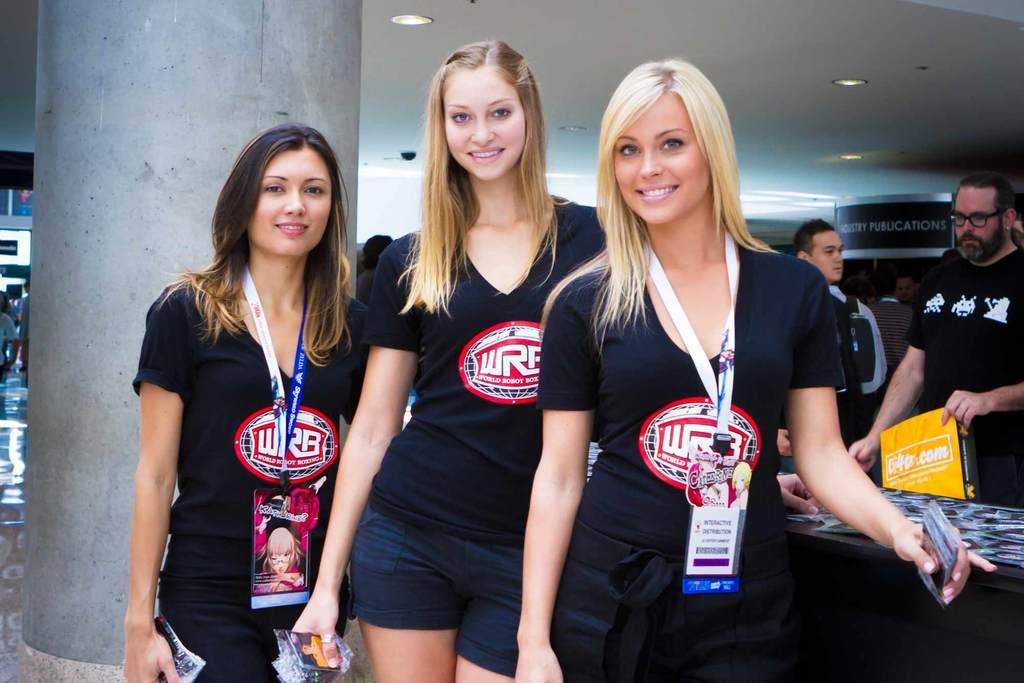<image>
Create a compact narrative representing the image presented. Models posing for camera wearing shirts that show WRB on them. 